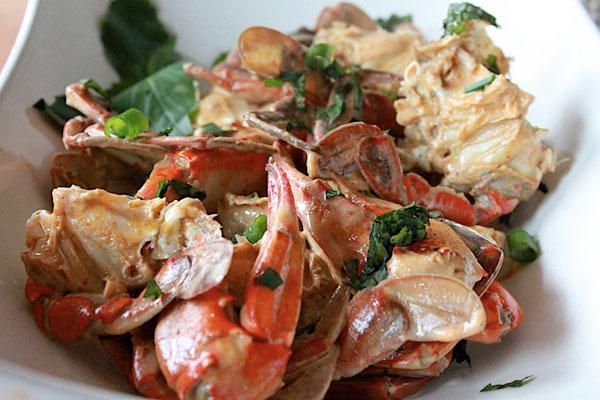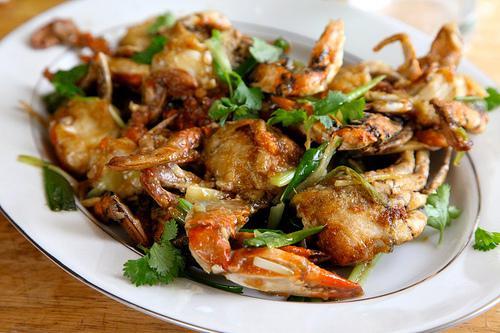The first image is the image on the left, the second image is the image on the right. Evaluate the accuracy of this statement regarding the images: "There is sauce next to the crab meat.". Is it true? Answer yes or no. No. The first image is the image on the left, the second image is the image on the right. Considering the images on both sides, is "There are at least two lemons and two lime to season crab legs." valid? Answer yes or no. No. 